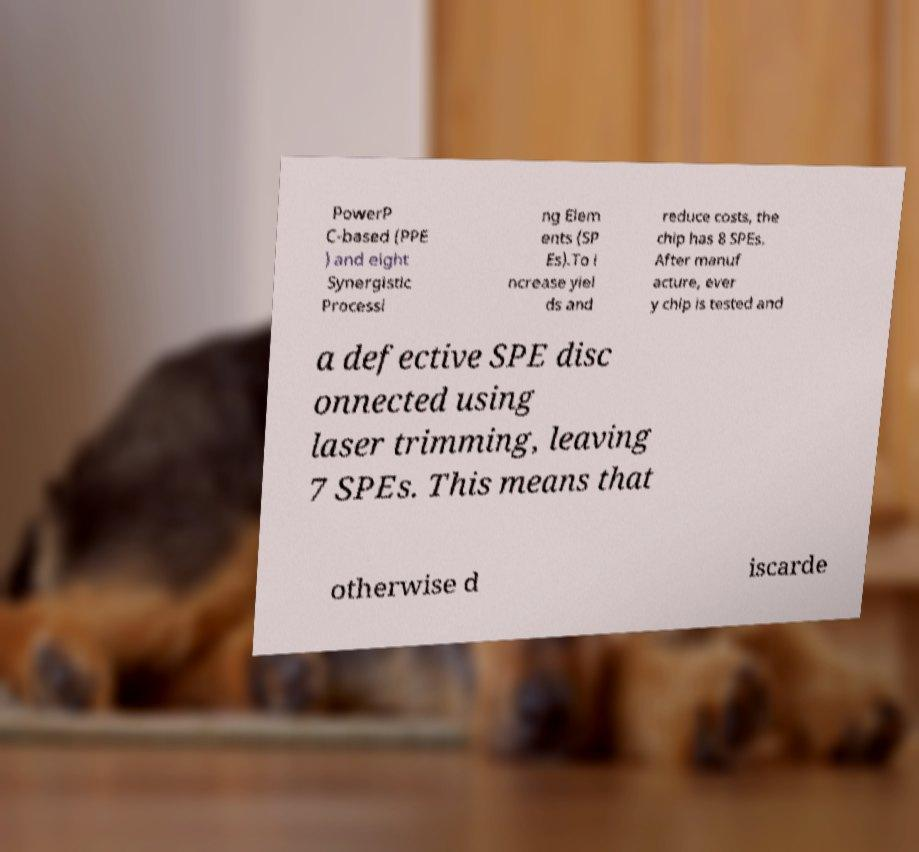I need the written content from this picture converted into text. Can you do that? PowerP C-based (PPE ) and eight Synergistic Processi ng Elem ents (SP Es).To i ncrease yiel ds and reduce costs, the chip has 8 SPEs. After manuf acture, ever y chip is tested and a defective SPE disc onnected using laser trimming, leaving 7 SPEs. This means that otherwise d iscarde 